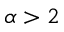<formula> <loc_0><loc_0><loc_500><loc_500>\alpha > 2</formula> 